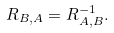<formula> <loc_0><loc_0><loc_500><loc_500>R _ { B , A } = R _ { A , B } ^ { - 1 } .</formula> 